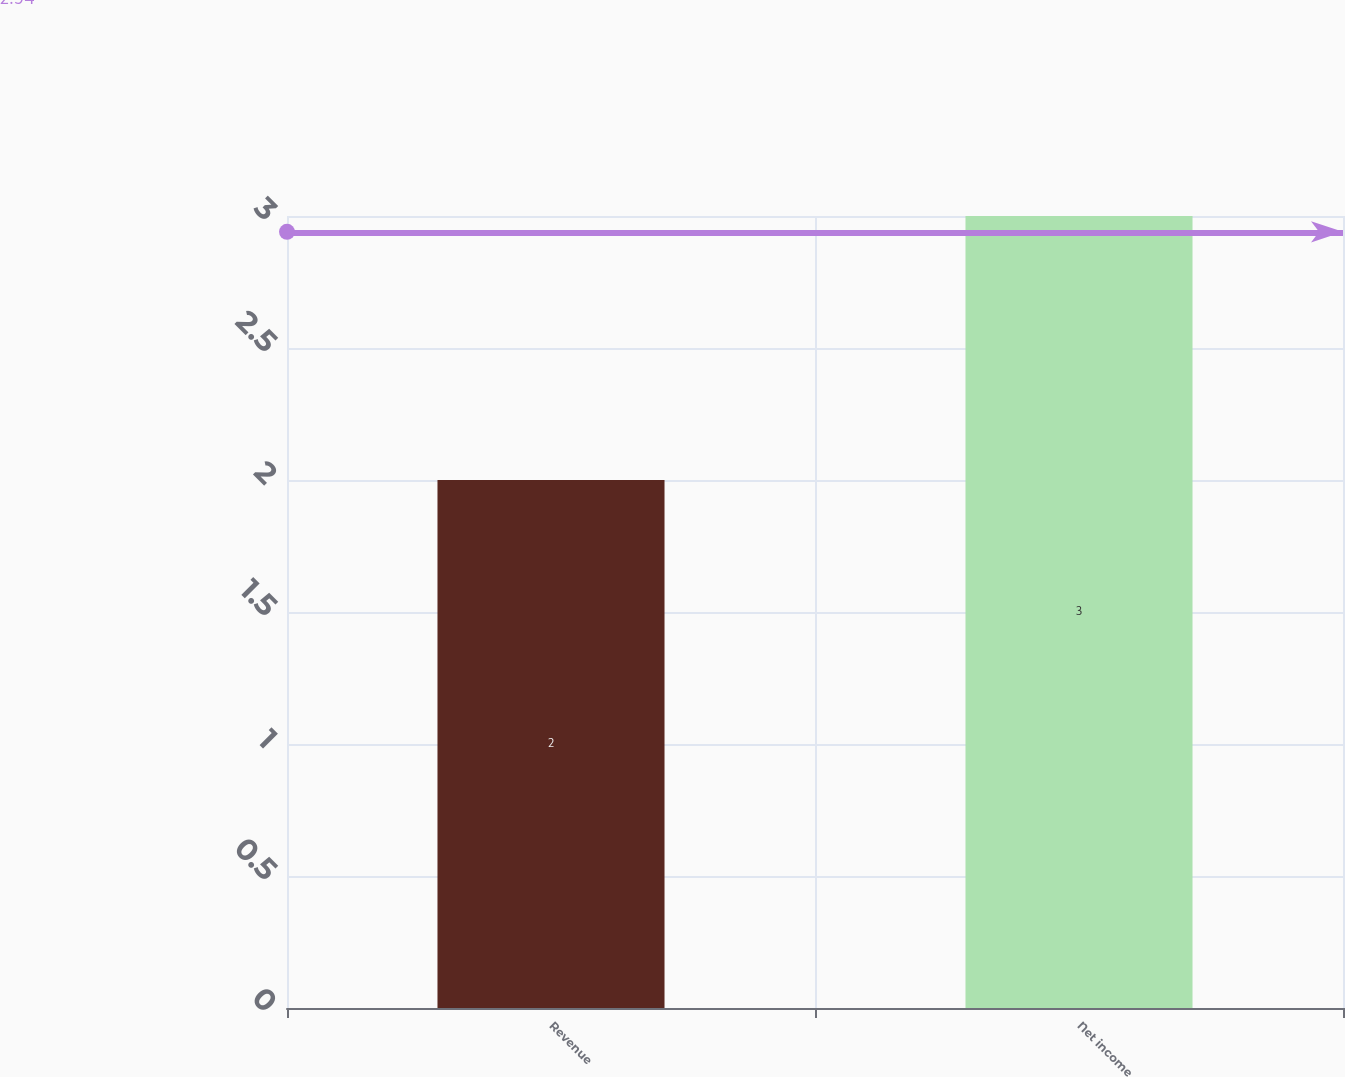Convert chart. <chart><loc_0><loc_0><loc_500><loc_500><bar_chart><fcel>Revenue<fcel>Net income<nl><fcel>2<fcel>3<nl></chart> 